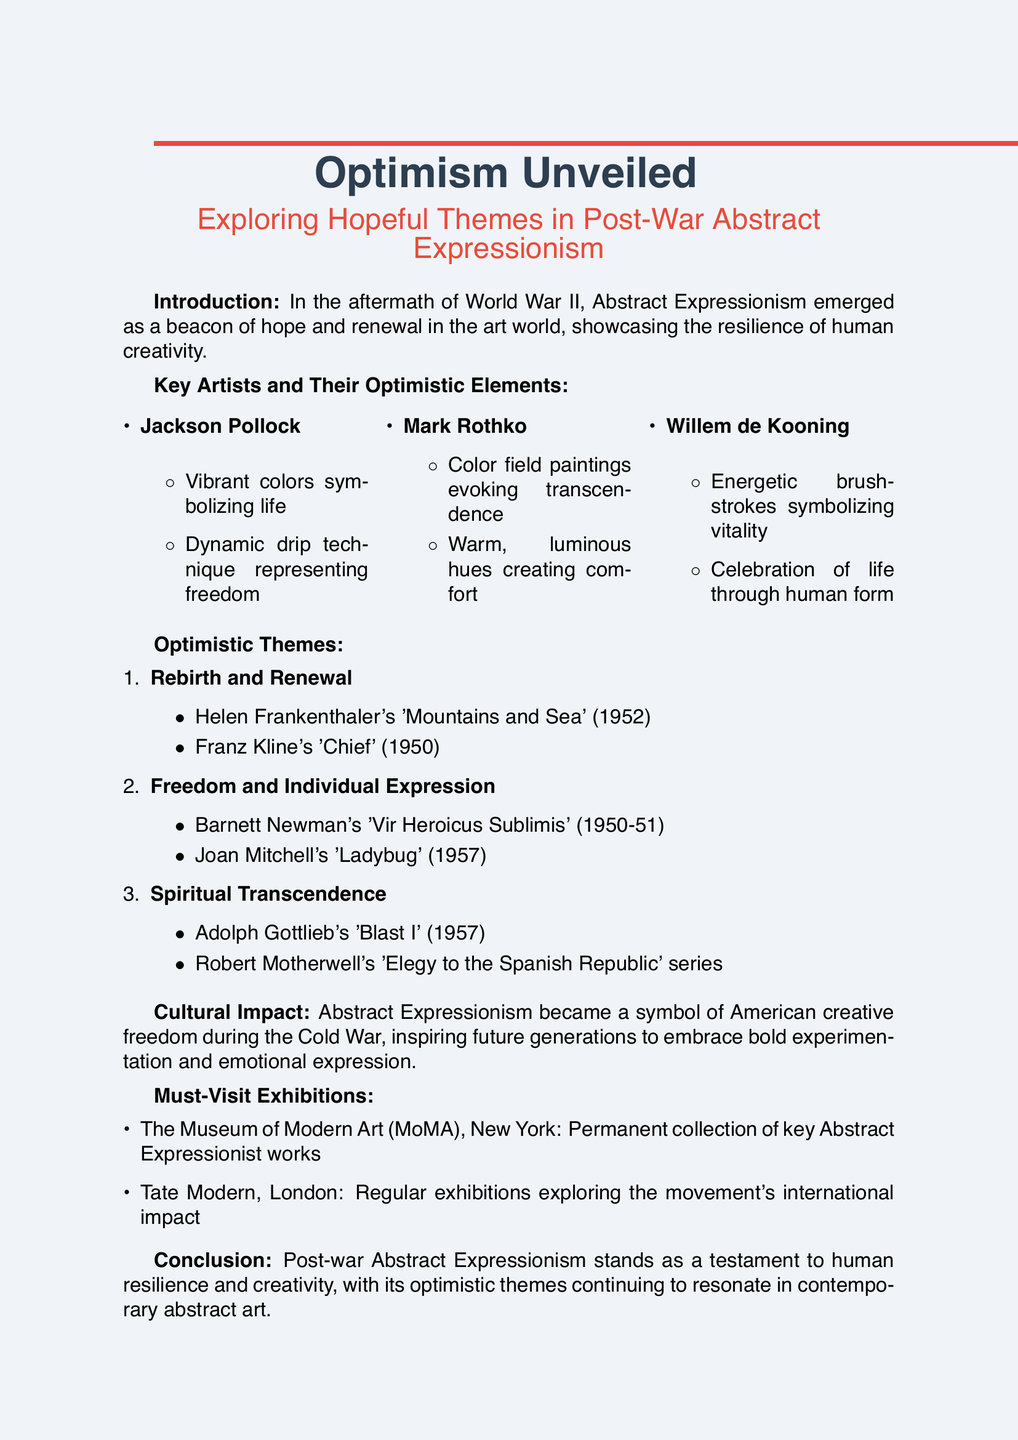What is the title of the lecture? The title of the lecture is explicitly mentioned at the beginning of the document as "Optimism Unveiled: Exploring Hopeful Themes in Post-War Abstract Expressionism."
Answer: Optimism Unveiled: Exploring Hopeful Themes in Post-War Abstract Expressionism Who is a key artist mentioned in the lecture? The document lists key artists, including Jackson Pollock, Mark Rothko, and Willem de Kooning.
Answer: Jackson Pollock What theme is associated with Helen Frankenthaler's work? The document describes "Rebirth and Renewal" and specifically links it to Helen Frankenthaler's "Mountains and Sea."
Answer: Rebirth and Renewal Which exhibition highlights are recommended in the document? The document mentions highlights from The Museum of Modern Art (MoMA) and Tate Modern, indicating key exhibitions worth visiting.
Answer: Permanent collection featuring key works of Abstract Expressionism What optimistic element is characteristic of Mark Rothko's art? The document lists attributes of Mark Rothko's works, such as "Large color field paintings evoking transcendence" as one of the optimistic elements.
Answer: Large color field paintings evoking transcendence Which year was Jackson Pollock's work created? While not explicitly stated, the document focuses on the post-war period; Pollock's key works are known to originate from the late 1940s to early 1950s.
Answer: 1940s to early 1950s What is a primary cultural impact of Abstract Expressionism? The document mentions that Abstract Expressionism symbolizes American creative freedom during the Cold War, emphasizing its cultural significance.
Answer: American creative freedom during the Cold War What is the conclusion about Post-war Abstract Expressionism? The document summarizes that Post-war Abstract Expressionism stands as a testament to human resilience and creativity.
Answer: Testament to human resilience and creativity What does Joan Mitchell's "Ladybug" express? The document describes Joan Mitchell's work as expressing "joyful freedom," highlighting the optimistic themes in her art.
Answer: Joyful freedom 